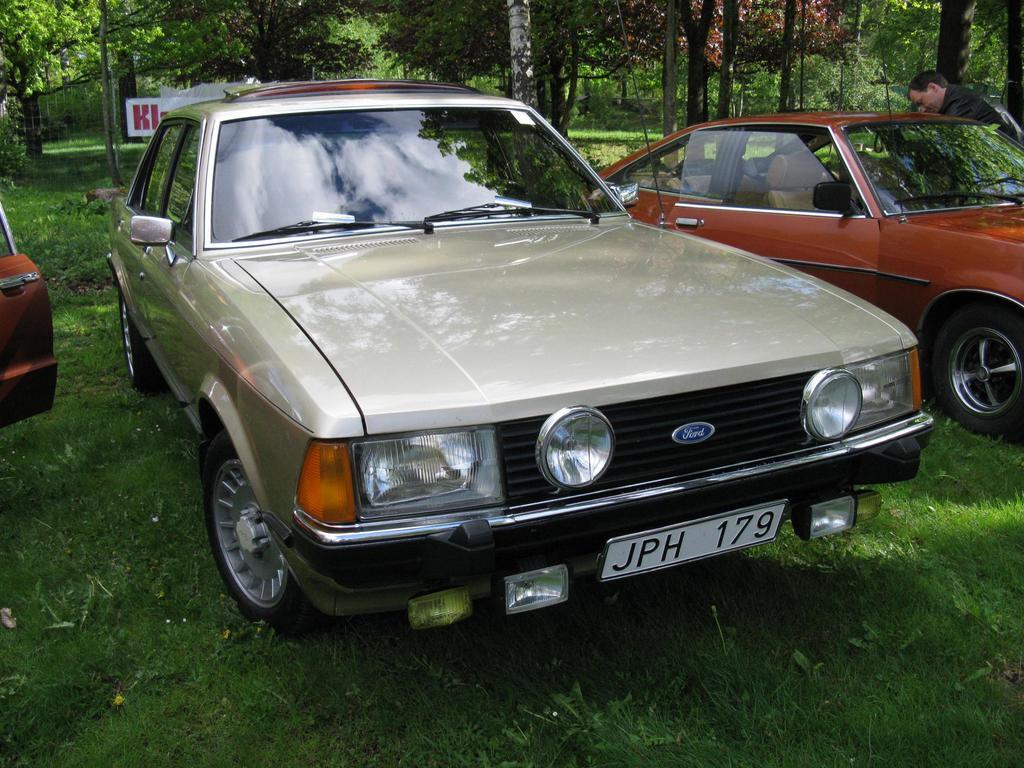Can you describe this image briefly? In the picture there are different cars parked on the grass and behind the cars there are many trees and beside the third car there is a man. 